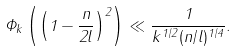<formula> <loc_0><loc_0><loc_500><loc_500>\Phi _ { k } \left ( \left ( 1 - \frac { n } { 2 l } \right ) ^ { 2 } \right ) \ll \frac { 1 } { k ^ { 1 / 2 } ( n / l ) ^ { 1 / 4 } } .</formula> 